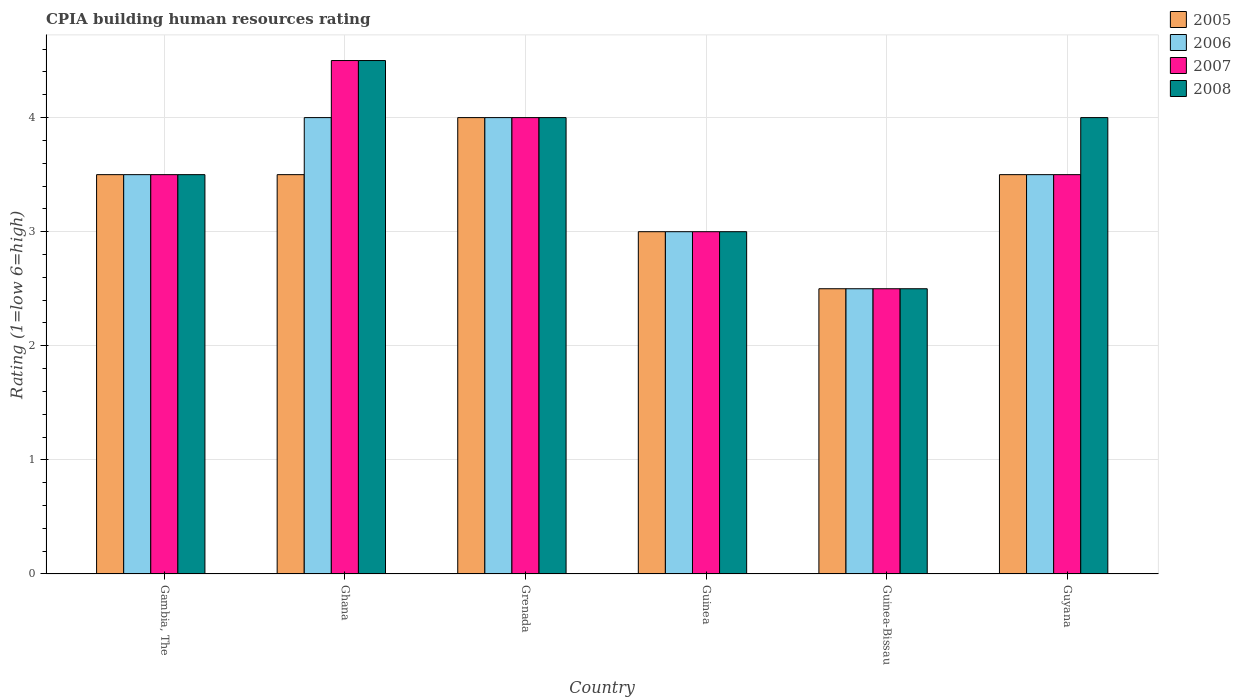How many different coloured bars are there?
Your response must be concise. 4. How many bars are there on the 1st tick from the left?
Your answer should be compact. 4. How many bars are there on the 2nd tick from the right?
Offer a very short reply. 4. What is the label of the 6th group of bars from the left?
Give a very brief answer. Guyana. In how many cases, is the number of bars for a given country not equal to the number of legend labels?
Keep it short and to the point. 0. What is the CPIA rating in 2007 in Guyana?
Provide a succinct answer. 3.5. Across all countries, what is the maximum CPIA rating in 2007?
Give a very brief answer. 4.5. In which country was the CPIA rating in 2006 minimum?
Offer a terse response. Guinea-Bissau. What is the total CPIA rating in 2008 in the graph?
Provide a short and direct response. 21.5. What is the difference between the CPIA rating in 2007 in Grenada and the CPIA rating in 2008 in Ghana?
Keep it short and to the point. -0.5. What is the average CPIA rating in 2007 per country?
Ensure brevity in your answer.  3.5. Is the CPIA rating in 2008 in Guinea less than that in Guinea-Bissau?
Offer a terse response. No. Is the difference between the CPIA rating in 2007 in Grenada and Guinea-Bissau greater than the difference between the CPIA rating in 2006 in Grenada and Guinea-Bissau?
Offer a terse response. No. What is the difference between the highest and the second highest CPIA rating in 2005?
Keep it short and to the point. -0.5. Is it the case that in every country, the sum of the CPIA rating in 2007 and CPIA rating in 2006 is greater than the sum of CPIA rating in 2008 and CPIA rating in 2005?
Provide a short and direct response. No. What does the 1st bar from the left in Gambia, The represents?
Give a very brief answer. 2005. Are all the bars in the graph horizontal?
Offer a terse response. No. What is the difference between two consecutive major ticks on the Y-axis?
Give a very brief answer. 1. Does the graph contain grids?
Ensure brevity in your answer.  Yes. Where does the legend appear in the graph?
Your answer should be very brief. Top right. How many legend labels are there?
Make the answer very short. 4. How are the legend labels stacked?
Give a very brief answer. Vertical. What is the title of the graph?
Keep it short and to the point. CPIA building human resources rating. Does "2012" appear as one of the legend labels in the graph?
Keep it short and to the point. No. What is the label or title of the Y-axis?
Offer a very short reply. Rating (1=low 6=high). What is the Rating (1=low 6=high) of 2005 in Gambia, The?
Your answer should be compact. 3.5. What is the Rating (1=low 6=high) in 2006 in Gambia, The?
Offer a very short reply. 3.5. What is the Rating (1=low 6=high) in 2007 in Gambia, The?
Ensure brevity in your answer.  3.5. What is the Rating (1=low 6=high) in 2006 in Ghana?
Make the answer very short. 4. What is the Rating (1=low 6=high) in 2007 in Ghana?
Your answer should be very brief. 4.5. What is the Rating (1=low 6=high) of 2008 in Ghana?
Keep it short and to the point. 4.5. What is the Rating (1=low 6=high) in 2005 in Grenada?
Ensure brevity in your answer.  4. What is the Rating (1=low 6=high) in 2006 in Grenada?
Your response must be concise. 4. What is the Rating (1=low 6=high) of 2008 in Grenada?
Offer a terse response. 4. What is the Rating (1=low 6=high) in 2005 in Guinea?
Your response must be concise. 3. What is the Rating (1=low 6=high) of 2006 in Guinea?
Your answer should be very brief. 3. What is the Rating (1=low 6=high) in 2007 in Guinea?
Give a very brief answer. 3. What is the Rating (1=low 6=high) of 2008 in Guinea?
Offer a terse response. 3. What is the Rating (1=low 6=high) in 2005 in Guinea-Bissau?
Offer a very short reply. 2.5. What is the Rating (1=low 6=high) in 2008 in Guinea-Bissau?
Your response must be concise. 2.5. What is the Rating (1=low 6=high) of 2005 in Guyana?
Provide a short and direct response. 3.5. What is the Rating (1=low 6=high) in 2006 in Guyana?
Offer a terse response. 3.5. Across all countries, what is the maximum Rating (1=low 6=high) of 2007?
Your answer should be very brief. 4.5. Across all countries, what is the minimum Rating (1=low 6=high) in 2005?
Make the answer very short. 2.5. What is the total Rating (1=low 6=high) of 2006 in the graph?
Your response must be concise. 20.5. What is the total Rating (1=low 6=high) in 2007 in the graph?
Give a very brief answer. 21. What is the total Rating (1=low 6=high) of 2008 in the graph?
Your response must be concise. 21.5. What is the difference between the Rating (1=low 6=high) of 2006 in Gambia, The and that in Ghana?
Give a very brief answer. -0.5. What is the difference between the Rating (1=low 6=high) of 2008 in Gambia, The and that in Ghana?
Offer a very short reply. -1. What is the difference between the Rating (1=low 6=high) in 2008 in Gambia, The and that in Grenada?
Keep it short and to the point. -0.5. What is the difference between the Rating (1=low 6=high) of 2005 in Gambia, The and that in Guinea?
Keep it short and to the point. 0.5. What is the difference between the Rating (1=low 6=high) of 2007 in Gambia, The and that in Guinea?
Offer a very short reply. 0.5. What is the difference between the Rating (1=low 6=high) in 2008 in Gambia, The and that in Guinea?
Give a very brief answer. 0.5. What is the difference between the Rating (1=low 6=high) of 2005 in Gambia, The and that in Guinea-Bissau?
Your response must be concise. 1. What is the difference between the Rating (1=low 6=high) of 2007 in Gambia, The and that in Guinea-Bissau?
Provide a succinct answer. 1. What is the difference between the Rating (1=low 6=high) in 2008 in Gambia, The and that in Guinea-Bissau?
Keep it short and to the point. 1. What is the difference between the Rating (1=low 6=high) of 2005 in Gambia, The and that in Guyana?
Provide a short and direct response. 0. What is the difference between the Rating (1=low 6=high) of 2006 in Ghana and that in Grenada?
Provide a succinct answer. 0. What is the difference between the Rating (1=low 6=high) in 2007 in Ghana and that in Grenada?
Give a very brief answer. 0.5. What is the difference between the Rating (1=low 6=high) of 2008 in Ghana and that in Grenada?
Offer a terse response. 0.5. What is the difference between the Rating (1=low 6=high) of 2008 in Ghana and that in Guinea?
Keep it short and to the point. 1.5. What is the difference between the Rating (1=low 6=high) in 2005 in Ghana and that in Guinea-Bissau?
Ensure brevity in your answer.  1. What is the difference between the Rating (1=low 6=high) in 2006 in Ghana and that in Guinea-Bissau?
Make the answer very short. 1.5. What is the difference between the Rating (1=low 6=high) of 2008 in Ghana and that in Guinea-Bissau?
Offer a terse response. 2. What is the difference between the Rating (1=low 6=high) of 2006 in Ghana and that in Guyana?
Keep it short and to the point. 0.5. What is the difference between the Rating (1=low 6=high) of 2006 in Grenada and that in Guinea?
Make the answer very short. 1. What is the difference between the Rating (1=low 6=high) of 2007 in Grenada and that in Guinea?
Your answer should be compact. 1. What is the difference between the Rating (1=low 6=high) of 2006 in Grenada and that in Guinea-Bissau?
Provide a short and direct response. 1.5. What is the difference between the Rating (1=low 6=high) in 2007 in Grenada and that in Guinea-Bissau?
Give a very brief answer. 1.5. What is the difference between the Rating (1=low 6=high) of 2008 in Grenada and that in Guinea-Bissau?
Make the answer very short. 1.5. What is the difference between the Rating (1=low 6=high) of 2007 in Grenada and that in Guyana?
Provide a succinct answer. 0.5. What is the difference between the Rating (1=low 6=high) in 2007 in Guinea and that in Guinea-Bissau?
Provide a short and direct response. 0.5. What is the difference between the Rating (1=low 6=high) in 2005 in Guinea and that in Guyana?
Give a very brief answer. -0.5. What is the difference between the Rating (1=low 6=high) in 2005 in Guinea-Bissau and that in Guyana?
Your answer should be very brief. -1. What is the difference between the Rating (1=low 6=high) in 2006 in Guinea-Bissau and that in Guyana?
Keep it short and to the point. -1. What is the difference between the Rating (1=low 6=high) of 2007 in Guinea-Bissau and that in Guyana?
Ensure brevity in your answer.  -1. What is the difference between the Rating (1=low 6=high) of 2008 in Guinea-Bissau and that in Guyana?
Ensure brevity in your answer.  -1.5. What is the difference between the Rating (1=low 6=high) of 2005 in Gambia, The and the Rating (1=low 6=high) of 2006 in Ghana?
Your answer should be very brief. -0.5. What is the difference between the Rating (1=low 6=high) of 2005 in Gambia, The and the Rating (1=low 6=high) of 2007 in Ghana?
Keep it short and to the point. -1. What is the difference between the Rating (1=low 6=high) of 2006 in Gambia, The and the Rating (1=low 6=high) of 2007 in Ghana?
Offer a terse response. -1. What is the difference between the Rating (1=low 6=high) of 2007 in Gambia, The and the Rating (1=low 6=high) of 2008 in Ghana?
Provide a succinct answer. -1. What is the difference between the Rating (1=low 6=high) of 2005 in Gambia, The and the Rating (1=low 6=high) of 2007 in Grenada?
Provide a short and direct response. -0.5. What is the difference between the Rating (1=low 6=high) in 2005 in Gambia, The and the Rating (1=low 6=high) in 2008 in Grenada?
Make the answer very short. -0.5. What is the difference between the Rating (1=low 6=high) of 2006 in Gambia, The and the Rating (1=low 6=high) of 2007 in Grenada?
Ensure brevity in your answer.  -0.5. What is the difference between the Rating (1=low 6=high) in 2007 in Gambia, The and the Rating (1=low 6=high) in 2008 in Grenada?
Keep it short and to the point. -0.5. What is the difference between the Rating (1=low 6=high) of 2005 in Gambia, The and the Rating (1=low 6=high) of 2007 in Guinea?
Ensure brevity in your answer.  0.5. What is the difference between the Rating (1=low 6=high) in 2005 in Gambia, The and the Rating (1=low 6=high) in 2008 in Guinea?
Keep it short and to the point. 0.5. What is the difference between the Rating (1=low 6=high) in 2006 in Gambia, The and the Rating (1=low 6=high) in 2008 in Guinea?
Offer a terse response. 0.5. What is the difference between the Rating (1=low 6=high) in 2007 in Gambia, The and the Rating (1=low 6=high) in 2008 in Guinea?
Make the answer very short. 0.5. What is the difference between the Rating (1=low 6=high) in 2005 in Gambia, The and the Rating (1=low 6=high) in 2007 in Guinea-Bissau?
Your response must be concise. 1. What is the difference between the Rating (1=low 6=high) in 2005 in Gambia, The and the Rating (1=low 6=high) in 2008 in Guinea-Bissau?
Your answer should be compact. 1. What is the difference between the Rating (1=low 6=high) of 2007 in Gambia, The and the Rating (1=low 6=high) of 2008 in Guinea-Bissau?
Provide a short and direct response. 1. What is the difference between the Rating (1=low 6=high) of 2005 in Gambia, The and the Rating (1=low 6=high) of 2007 in Guyana?
Offer a very short reply. 0. What is the difference between the Rating (1=low 6=high) of 2006 in Gambia, The and the Rating (1=low 6=high) of 2007 in Guyana?
Your answer should be very brief. 0. What is the difference between the Rating (1=low 6=high) of 2006 in Gambia, The and the Rating (1=low 6=high) of 2008 in Guyana?
Make the answer very short. -0.5. What is the difference between the Rating (1=low 6=high) in 2005 in Ghana and the Rating (1=low 6=high) in 2006 in Grenada?
Your response must be concise. -0.5. What is the difference between the Rating (1=low 6=high) of 2005 in Ghana and the Rating (1=low 6=high) of 2008 in Grenada?
Your response must be concise. -0.5. What is the difference between the Rating (1=low 6=high) of 2007 in Ghana and the Rating (1=low 6=high) of 2008 in Grenada?
Offer a terse response. 0.5. What is the difference between the Rating (1=low 6=high) of 2005 in Ghana and the Rating (1=low 6=high) of 2006 in Guinea?
Provide a succinct answer. 0.5. What is the difference between the Rating (1=low 6=high) of 2005 in Ghana and the Rating (1=low 6=high) of 2007 in Guinea?
Make the answer very short. 0.5. What is the difference between the Rating (1=low 6=high) in 2006 in Ghana and the Rating (1=low 6=high) in 2007 in Guinea?
Offer a very short reply. 1. What is the difference between the Rating (1=low 6=high) in 2006 in Ghana and the Rating (1=low 6=high) in 2008 in Guinea?
Keep it short and to the point. 1. What is the difference between the Rating (1=low 6=high) of 2007 in Ghana and the Rating (1=low 6=high) of 2008 in Guinea?
Give a very brief answer. 1.5. What is the difference between the Rating (1=low 6=high) in 2007 in Ghana and the Rating (1=low 6=high) in 2008 in Guinea-Bissau?
Provide a short and direct response. 2. What is the difference between the Rating (1=low 6=high) in 2005 in Ghana and the Rating (1=low 6=high) in 2006 in Guyana?
Offer a terse response. 0. What is the difference between the Rating (1=low 6=high) of 2005 in Ghana and the Rating (1=low 6=high) of 2007 in Guyana?
Your answer should be very brief. 0. What is the difference between the Rating (1=low 6=high) in 2005 in Ghana and the Rating (1=low 6=high) in 2008 in Guyana?
Offer a very short reply. -0.5. What is the difference between the Rating (1=low 6=high) in 2006 in Ghana and the Rating (1=low 6=high) in 2007 in Guyana?
Offer a terse response. 0.5. What is the difference between the Rating (1=low 6=high) in 2005 in Grenada and the Rating (1=low 6=high) in 2006 in Guinea?
Provide a succinct answer. 1. What is the difference between the Rating (1=low 6=high) of 2006 in Grenada and the Rating (1=low 6=high) of 2007 in Guinea?
Offer a very short reply. 1. What is the difference between the Rating (1=low 6=high) of 2006 in Grenada and the Rating (1=low 6=high) of 2008 in Guinea?
Your answer should be compact. 1. What is the difference between the Rating (1=low 6=high) of 2007 in Grenada and the Rating (1=low 6=high) of 2008 in Guinea?
Keep it short and to the point. 1. What is the difference between the Rating (1=low 6=high) of 2005 in Grenada and the Rating (1=low 6=high) of 2007 in Guinea-Bissau?
Your response must be concise. 1.5. What is the difference between the Rating (1=low 6=high) in 2005 in Grenada and the Rating (1=low 6=high) in 2008 in Guinea-Bissau?
Give a very brief answer. 1.5. What is the difference between the Rating (1=low 6=high) in 2006 in Grenada and the Rating (1=low 6=high) in 2008 in Guinea-Bissau?
Give a very brief answer. 1.5. What is the difference between the Rating (1=low 6=high) of 2007 in Grenada and the Rating (1=low 6=high) of 2008 in Guinea-Bissau?
Your answer should be compact. 1.5. What is the difference between the Rating (1=low 6=high) in 2005 in Grenada and the Rating (1=low 6=high) in 2007 in Guyana?
Provide a succinct answer. 0.5. What is the difference between the Rating (1=low 6=high) of 2006 in Grenada and the Rating (1=low 6=high) of 2007 in Guyana?
Your answer should be compact. 0.5. What is the difference between the Rating (1=low 6=high) of 2006 in Grenada and the Rating (1=low 6=high) of 2008 in Guyana?
Provide a succinct answer. 0. What is the difference between the Rating (1=low 6=high) in 2005 in Guinea and the Rating (1=low 6=high) in 2008 in Guinea-Bissau?
Keep it short and to the point. 0.5. What is the difference between the Rating (1=low 6=high) of 2006 in Guinea and the Rating (1=low 6=high) of 2007 in Guinea-Bissau?
Your answer should be compact. 0.5. What is the difference between the Rating (1=low 6=high) of 2006 in Guinea and the Rating (1=low 6=high) of 2008 in Guinea-Bissau?
Your answer should be very brief. 0.5. What is the difference between the Rating (1=low 6=high) in 2007 in Guinea and the Rating (1=low 6=high) in 2008 in Guinea-Bissau?
Your response must be concise. 0.5. What is the difference between the Rating (1=low 6=high) in 2006 in Guinea and the Rating (1=low 6=high) in 2007 in Guyana?
Your response must be concise. -0.5. What is the difference between the Rating (1=low 6=high) of 2006 in Guinea and the Rating (1=low 6=high) of 2008 in Guyana?
Your answer should be very brief. -1. What is the difference between the Rating (1=low 6=high) in 2007 in Guinea and the Rating (1=low 6=high) in 2008 in Guyana?
Provide a short and direct response. -1. What is the difference between the Rating (1=low 6=high) in 2005 in Guinea-Bissau and the Rating (1=low 6=high) in 2008 in Guyana?
Provide a short and direct response. -1.5. What is the average Rating (1=low 6=high) of 2005 per country?
Your response must be concise. 3.33. What is the average Rating (1=low 6=high) in 2006 per country?
Make the answer very short. 3.42. What is the average Rating (1=low 6=high) in 2008 per country?
Your response must be concise. 3.58. What is the difference between the Rating (1=low 6=high) in 2005 and Rating (1=low 6=high) in 2007 in Gambia, The?
Your answer should be very brief. 0. What is the difference between the Rating (1=low 6=high) of 2005 and Rating (1=low 6=high) of 2008 in Gambia, The?
Give a very brief answer. 0. What is the difference between the Rating (1=low 6=high) of 2005 and Rating (1=low 6=high) of 2008 in Ghana?
Provide a short and direct response. -1. What is the difference between the Rating (1=low 6=high) of 2006 and Rating (1=low 6=high) of 2007 in Ghana?
Offer a terse response. -0.5. What is the difference between the Rating (1=low 6=high) in 2007 and Rating (1=low 6=high) in 2008 in Ghana?
Offer a terse response. 0. What is the difference between the Rating (1=low 6=high) in 2005 and Rating (1=low 6=high) in 2006 in Grenada?
Your answer should be compact. 0. What is the difference between the Rating (1=low 6=high) in 2005 and Rating (1=low 6=high) in 2007 in Grenada?
Provide a short and direct response. 0. What is the difference between the Rating (1=low 6=high) of 2005 and Rating (1=low 6=high) of 2008 in Grenada?
Ensure brevity in your answer.  0. What is the difference between the Rating (1=low 6=high) of 2006 and Rating (1=low 6=high) of 2007 in Grenada?
Make the answer very short. 0. What is the difference between the Rating (1=low 6=high) in 2005 and Rating (1=low 6=high) in 2007 in Guinea?
Your response must be concise. 0. What is the difference between the Rating (1=low 6=high) of 2006 and Rating (1=low 6=high) of 2008 in Guinea?
Offer a terse response. 0. What is the difference between the Rating (1=low 6=high) of 2007 and Rating (1=low 6=high) of 2008 in Guinea?
Your answer should be very brief. 0. What is the difference between the Rating (1=low 6=high) in 2005 and Rating (1=low 6=high) in 2006 in Guinea-Bissau?
Offer a terse response. 0. What is the difference between the Rating (1=low 6=high) in 2005 and Rating (1=low 6=high) in 2007 in Guinea-Bissau?
Offer a terse response. 0. What is the difference between the Rating (1=low 6=high) in 2006 and Rating (1=low 6=high) in 2007 in Guinea-Bissau?
Offer a terse response. 0. What is the difference between the Rating (1=low 6=high) of 2006 and Rating (1=low 6=high) of 2008 in Guinea-Bissau?
Provide a succinct answer. 0. What is the difference between the Rating (1=low 6=high) of 2005 and Rating (1=low 6=high) of 2006 in Guyana?
Keep it short and to the point. 0. What is the difference between the Rating (1=low 6=high) of 2005 and Rating (1=low 6=high) of 2008 in Guyana?
Provide a short and direct response. -0.5. What is the difference between the Rating (1=low 6=high) of 2006 and Rating (1=low 6=high) of 2007 in Guyana?
Give a very brief answer. 0. What is the difference between the Rating (1=low 6=high) in 2006 and Rating (1=low 6=high) in 2008 in Guyana?
Offer a very short reply. -0.5. What is the ratio of the Rating (1=low 6=high) of 2005 in Gambia, The to that in Ghana?
Keep it short and to the point. 1. What is the ratio of the Rating (1=low 6=high) of 2006 in Gambia, The to that in Ghana?
Give a very brief answer. 0.88. What is the ratio of the Rating (1=low 6=high) in 2008 in Gambia, The to that in Ghana?
Make the answer very short. 0.78. What is the ratio of the Rating (1=low 6=high) of 2005 in Gambia, The to that in Guinea?
Your answer should be compact. 1.17. What is the ratio of the Rating (1=low 6=high) of 2006 in Gambia, The to that in Guinea?
Make the answer very short. 1.17. What is the ratio of the Rating (1=low 6=high) of 2005 in Gambia, The to that in Guinea-Bissau?
Ensure brevity in your answer.  1.4. What is the ratio of the Rating (1=low 6=high) in 2005 in Gambia, The to that in Guyana?
Your answer should be very brief. 1. What is the ratio of the Rating (1=low 6=high) in 2006 in Gambia, The to that in Guyana?
Offer a terse response. 1. What is the ratio of the Rating (1=low 6=high) in 2007 in Gambia, The to that in Guyana?
Keep it short and to the point. 1. What is the ratio of the Rating (1=low 6=high) in 2008 in Gambia, The to that in Guyana?
Ensure brevity in your answer.  0.88. What is the ratio of the Rating (1=low 6=high) of 2005 in Ghana to that in Grenada?
Provide a short and direct response. 0.88. What is the ratio of the Rating (1=low 6=high) in 2005 in Ghana to that in Guinea?
Make the answer very short. 1.17. What is the ratio of the Rating (1=low 6=high) in 2008 in Ghana to that in Guinea?
Your answer should be compact. 1.5. What is the ratio of the Rating (1=low 6=high) in 2005 in Ghana to that in Guinea-Bissau?
Give a very brief answer. 1.4. What is the ratio of the Rating (1=low 6=high) in 2006 in Ghana to that in Guinea-Bissau?
Offer a terse response. 1.6. What is the ratio of the Rating (1=low 6=high) of 2007 in Ghana to that in Guinea-Bissau?
Ensure brevity in your answer.  1.8. What is the ratio of the Rating (1=low 6=high) in 2008 in Ghana to that in Guinea-Bissau?
Keep it short and to the point. 1.8. What is the ratio of the Rating (1=low 6=high) in 2005 in Ghana to that in Guyana?
Your answer should be compact. 1. What is the ratio of the Rating (1=low 6=high) of 2006 in Ghana to that in Guyana?
Ensure brevity in your answer.  1.14. What is the ratio of the Rating (1=low 6=high) in 2005 in Grenada to that in Guinea?
Your answer should be very brief. 1.33. What is the ratio of the Rating (1=low 6=high) of 2005 in Grenada to that in Guinea-Bissau?
Your answer should be very brief. 1.6. What is the ratio of the Rating (1=low 6=high) in 2006 in Grenada to that in Guinea-Bissau?
Provide a short and direct response. 1.6. What is the ratio of the Rating (1=low 6=high) in 2006 in Grenada to that in Guyana?
Your answer should be very brief. 1.14. What is the ratio of the Rating (1=low 6=high) in 2007 in Grenada to that in Guyana?
Offer a terse response. 1.14. What is the ratio of the Rating (1=low 6=high) of 2005 in Guinea to that in Guinea-Bissau?
Offer a very short reply. 1.2. What is the ratio of the Rating (1=low 6=high) of 2006 in Guinea to that in Guinea-Bissau?
Make the answer very short. 1.2. What is the ratio of the Rating (1=low 6=high) in 2005 in Guinea to that in Guyana?
Offer a very short reply. 0.86. What is the ratio of the Rating (1=low 6=high) in 2006 in Guinea to that in Guyana?
Give a very brief answer. 0.86. What is the ratio of the Rating (1=low 6=high) of 2008 in Guinea to that in Guyana?
Your answer should be very brief. 0.75. What is the ratio of the Rating (1=low 6=high) in 2007 in Guinea-Bissau to that in Guyana?
Give a very brief answer. 0.71. What is the ratio of the Rating (1=low 6=high) of 2008 in Guinea-Bissau to that in Guyana?
Provide a short and direct response. 0.62. What is the difference between the highest and the second highest Rating (1=low 6=high) of 2005?
Your answer should be very brief. 0.5. What is the difference between the highest and the second highest Rating (1=low 6=high) of 2007?
Provide a succinct answer. 0.5. What is the difference between the highest and the lowest Rating (1=low 6=high) in 2005?
Offer a very short reply. 1.5. What is the difference between the highest and the lowest Rating (1=low 6=high) in 2008?
Make the answer very short. 2. 